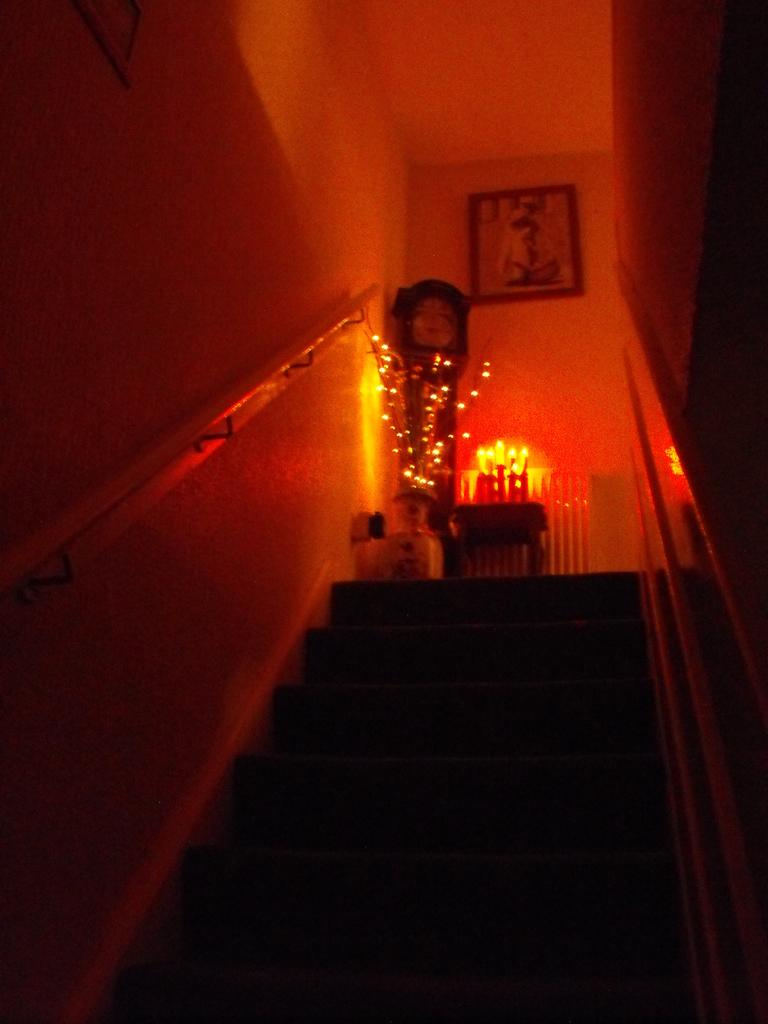What type of architectural feature is present in the image? There are stairs in the image. What type of clock can be seen in the image? There is a Victorian clock in the image. What type of illumination is present in the image? There are lights in the image. What other objects can be seen in the image? There are other objects in the image, but their specific details are not mentioned in the provided facts. What is attached to the wall in the background of the image? There is a frame attached to the wall in the background of the image. How does the hole in the wall help the people in the image? There is no hole in the wall mentioned in the image, so it cannot help anyone. 